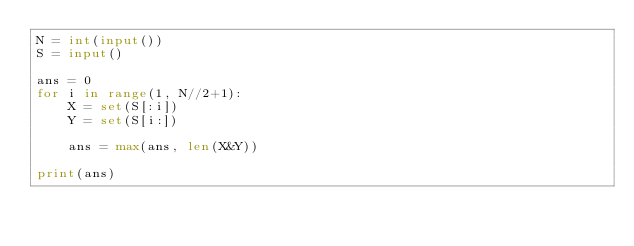<code> <loc_0><loc_0><loc_500><loc_500><_Python_>N = int(input())
S = input()

ans = 0
for i in range(1, N//2+1):
    X = set(S[:i])
    Y = set(S[i:])

    ans = max(ans, len(X&Y))

print(ans)
</code> 